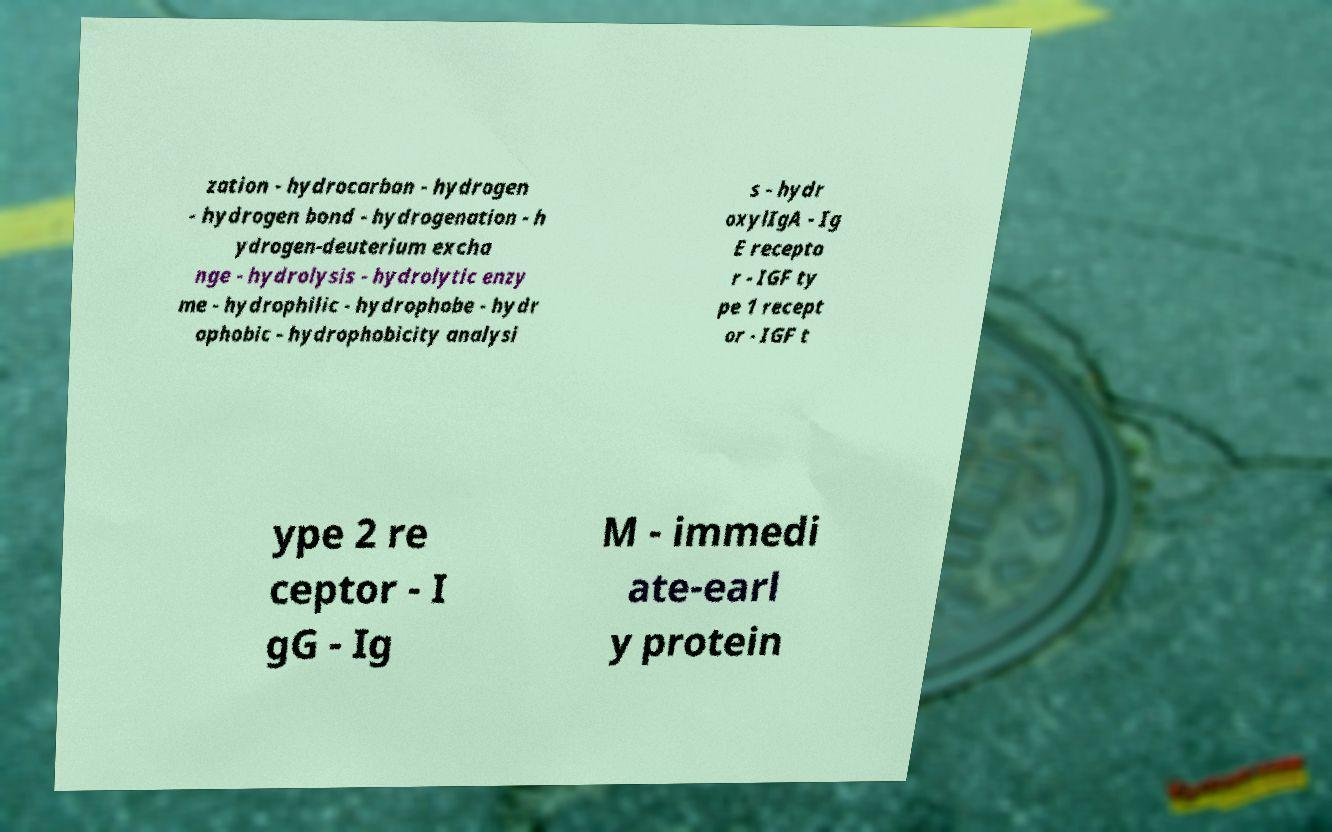Please read and relay the text visible in this image. What does it say? zation - hydrocarbon - hydrogen - hydrogen bond - hydrogenation - h ydrogen-deuterium excha nge - hydrolysis - hydrolytic enzy me - hydrophilic - hydrophobe - hydr ophobic - hydrophobicity analysi s - hydr oxylIgA - Ig E recepto r - IGF ty pe 1 recept or - IGF t ype 2 re ceptor - I gG - Ig M - immedi ate-earl y protein 